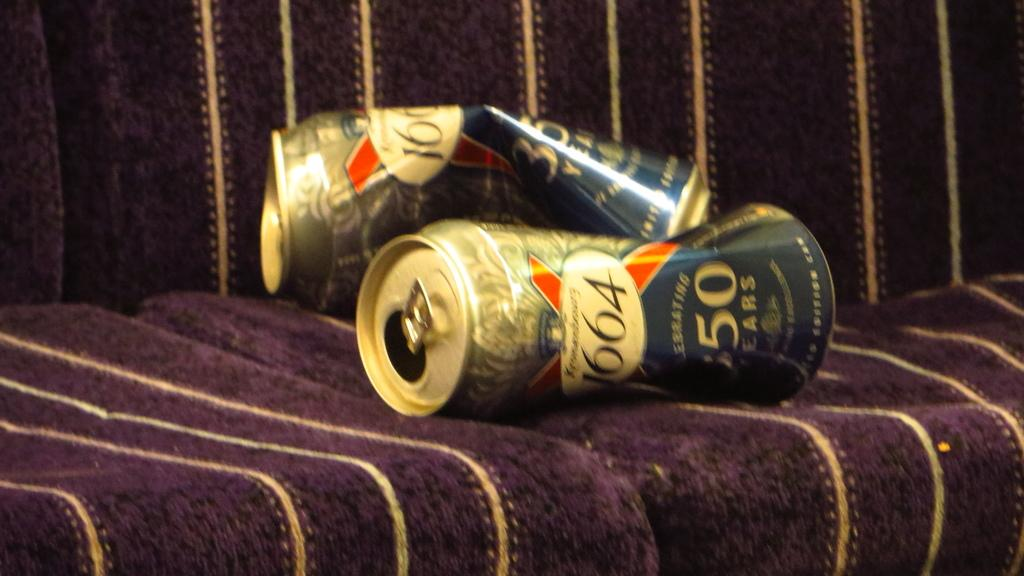<image>
Provide a brief description of the given image. A couple of crumpled Kronenbourg 1664 beer cans lie empty on a couch. 